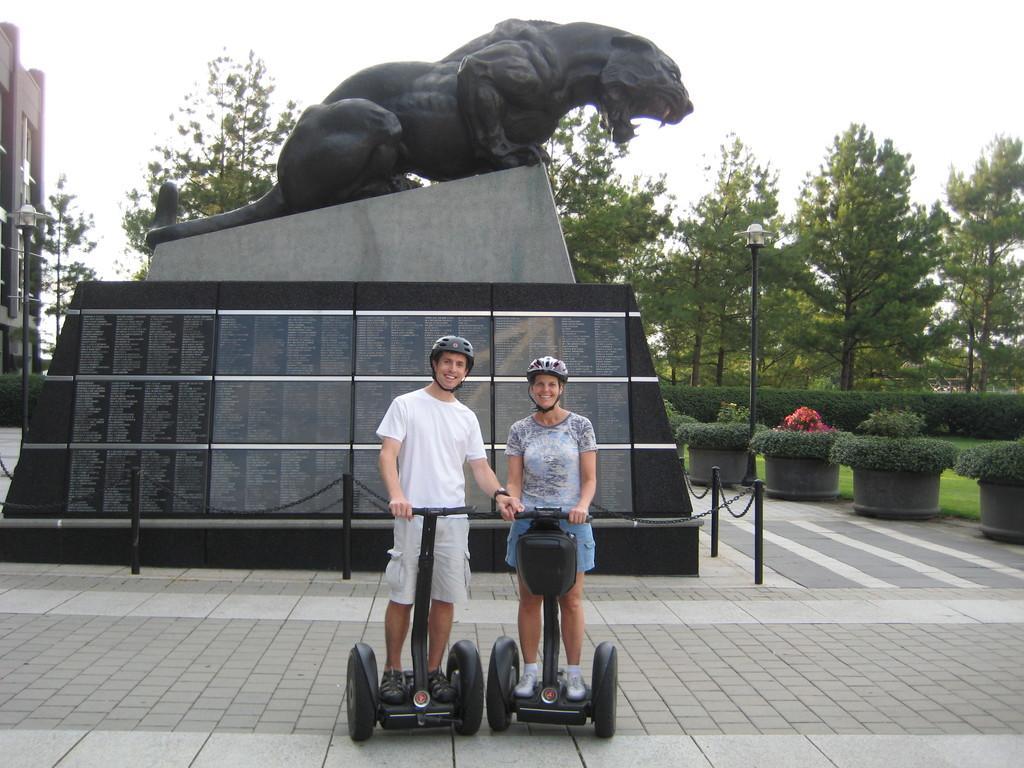Could you give a brief overview of what you see in this image? In this image I can see a black color statue. In front I can see two people are standing on the black color vehicles. Background I can see trees,light-poles,building and flower pots. The sky is in white color. 